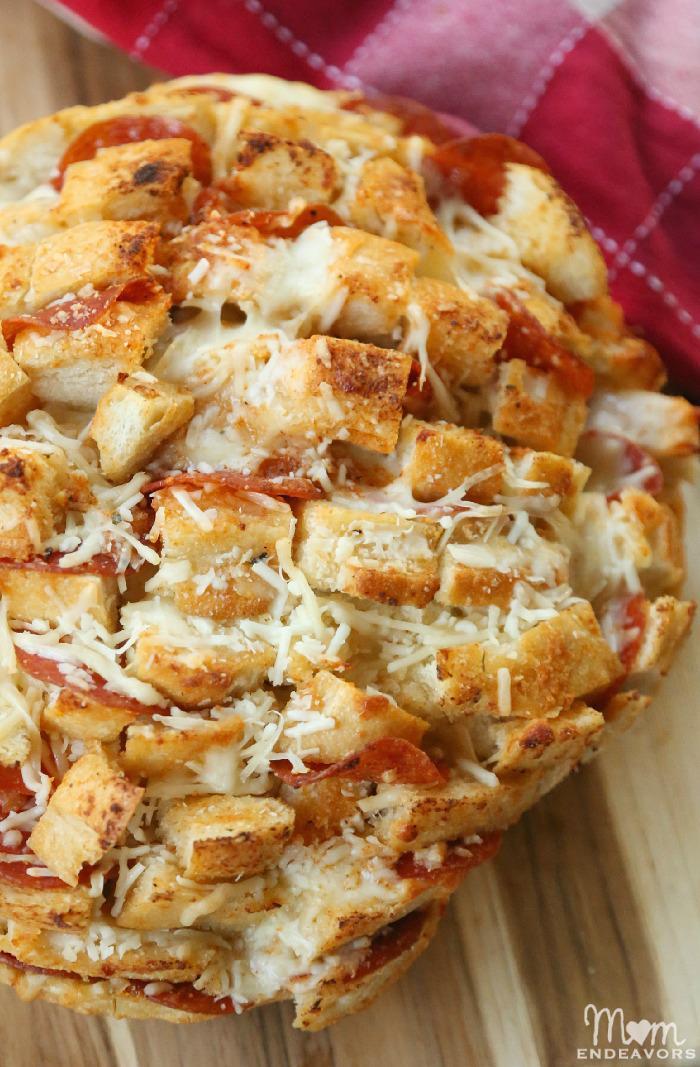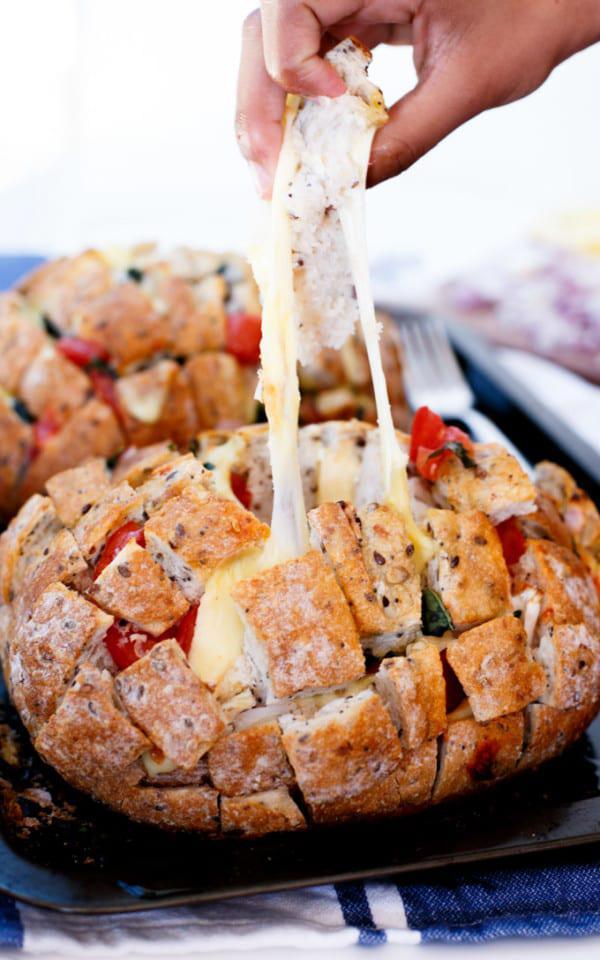The first image is the image on the left, the second image is the image on the right. For the images displayed, is the sentence "IN at least one image there is a pull apart pizza sitting on a black surface." factually correct? Answer yes or no. Yes. 